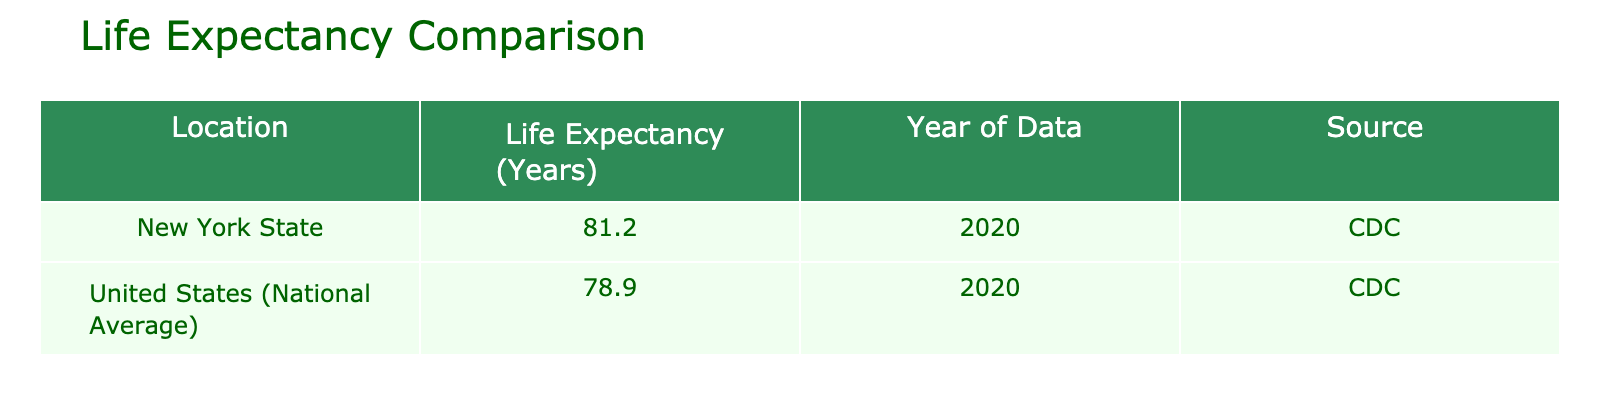What is the life expectancy in New York State? The table lists the life expectancy for New York State as 81.2 years.
Answer: 81.2 What is the national average life expectancy? The table shows the life expectancy for the United States (national average) as 78.9 years.
Answer: 78.9 How much higher is the life expectancy in New York State compared to the national average? To find the difference, subtract the national average (78.9) from New York State's life expectancy (81.2): 81.2 - 78.9 = 2.3 years.
Answer: 2.3 years Is the life expectancy in Rochester higher than the national average? The table shows that New York State has a life expectancy of 81.2 years, which is higher than the national average of 78.9 years, suggesting Rochester's life expectancy is likely also higher.
Answer: Yes What would be the average life expectancy if we considered the life expectancy of both New York State and the national average? Calculate the average by adding the two life expectancies (81.2 + 78.9 = 160.1) and dividing by 2: 160.1 / 2 = 80.05 years.
Answer: 80.05 years 